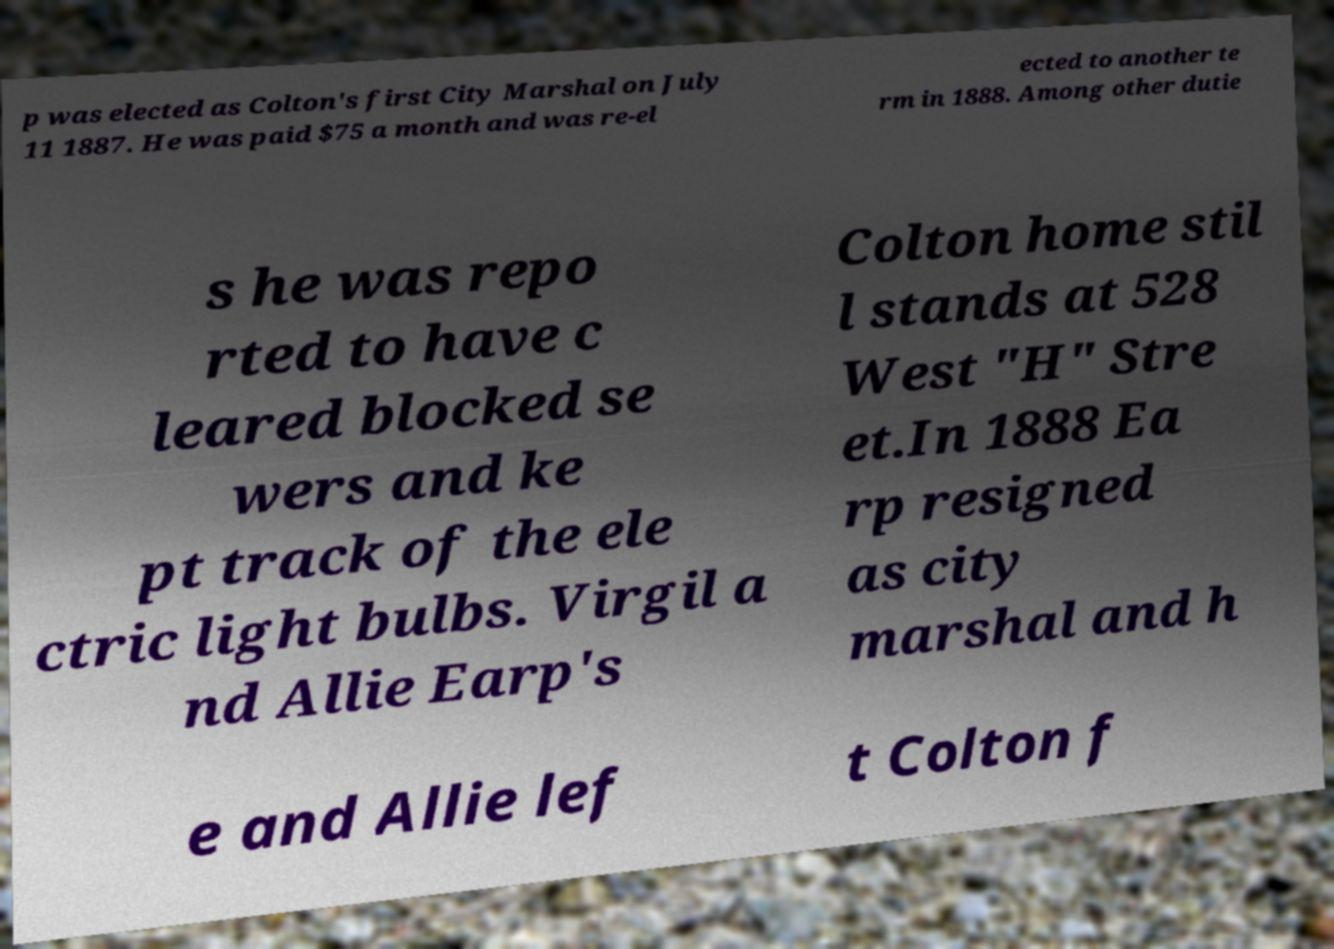Could you assist in decoding the text presented in this image and type it out clearly? p was elected as Colton's first City Marshal on July 11 1887. He was paid $75 a month and was re-el ected to another te rm in 1888. Among other dutie s he was repo rted to have c leared blocked se wers and ke pt track of the ele ctric light bulbs. Virgil a nd Allie Earp's Colton home stil l stands at 528 West "H" Stre et.In 1888 Ea rp resigned as city marshal and h e and Allie lef t Colton f 